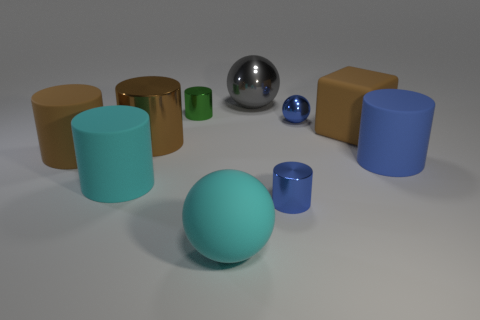Subtract all blue spheres. How many spheres are left? 2 Subtract 2 cylinders. How many cylinders are left? 4 Add 1 big brown rubber cylinders. How many big brown rubber cylinders exist? 2 Subtract all brown cylinders. How many cylinders are left? 4 Subtract 1 gray spheres. How many objects are left? 9 Subtract all spheres. How many objects are left? 7 Subtract all red balls. Subtract all yellow cubes. How many balls are left? 3 Subtract all gray cylinders. How many gray spheres are left? 1 Subtract all big brown metal balls. Subtract all green metallic things. How many objects are left? 9 Add 8 big cubes. How many big cubes are left? 9 